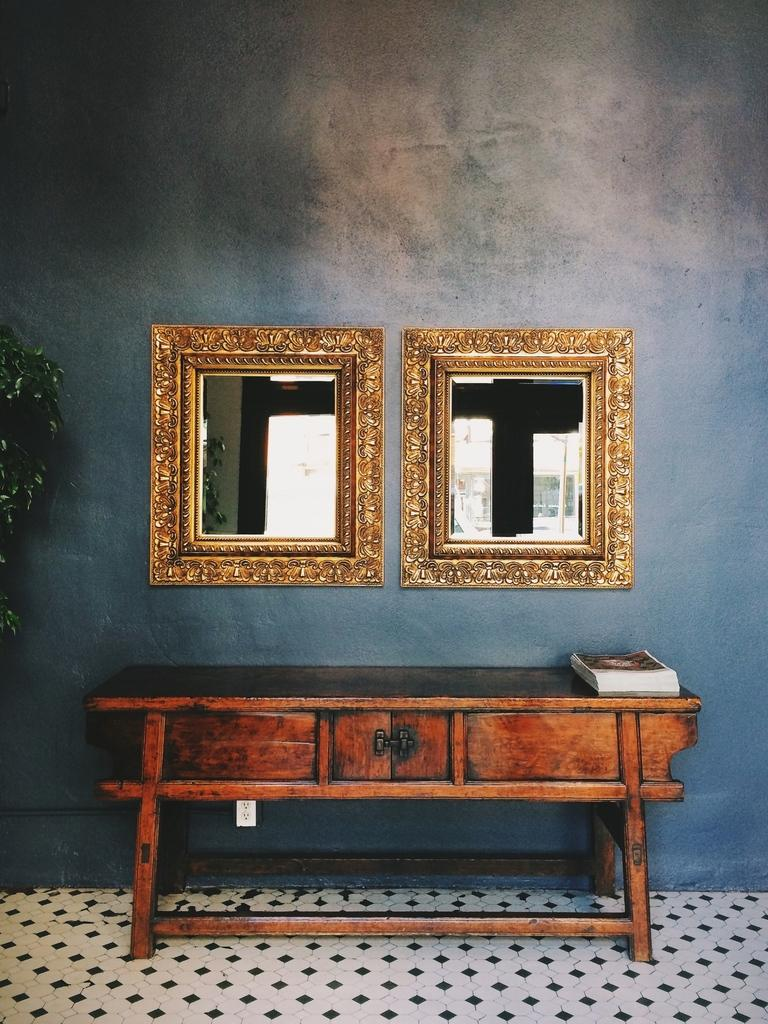What is the main piece of furniture in the image? There is a table in the image. What object is placed on the table? There is a book on the table. How many mirrors are visible in the image? There are two mirrors in the image. What type of insect can be seen crawling on the book in the image? There are no insects visible in the image, and therefore no insects can be seen crawling on the book. 